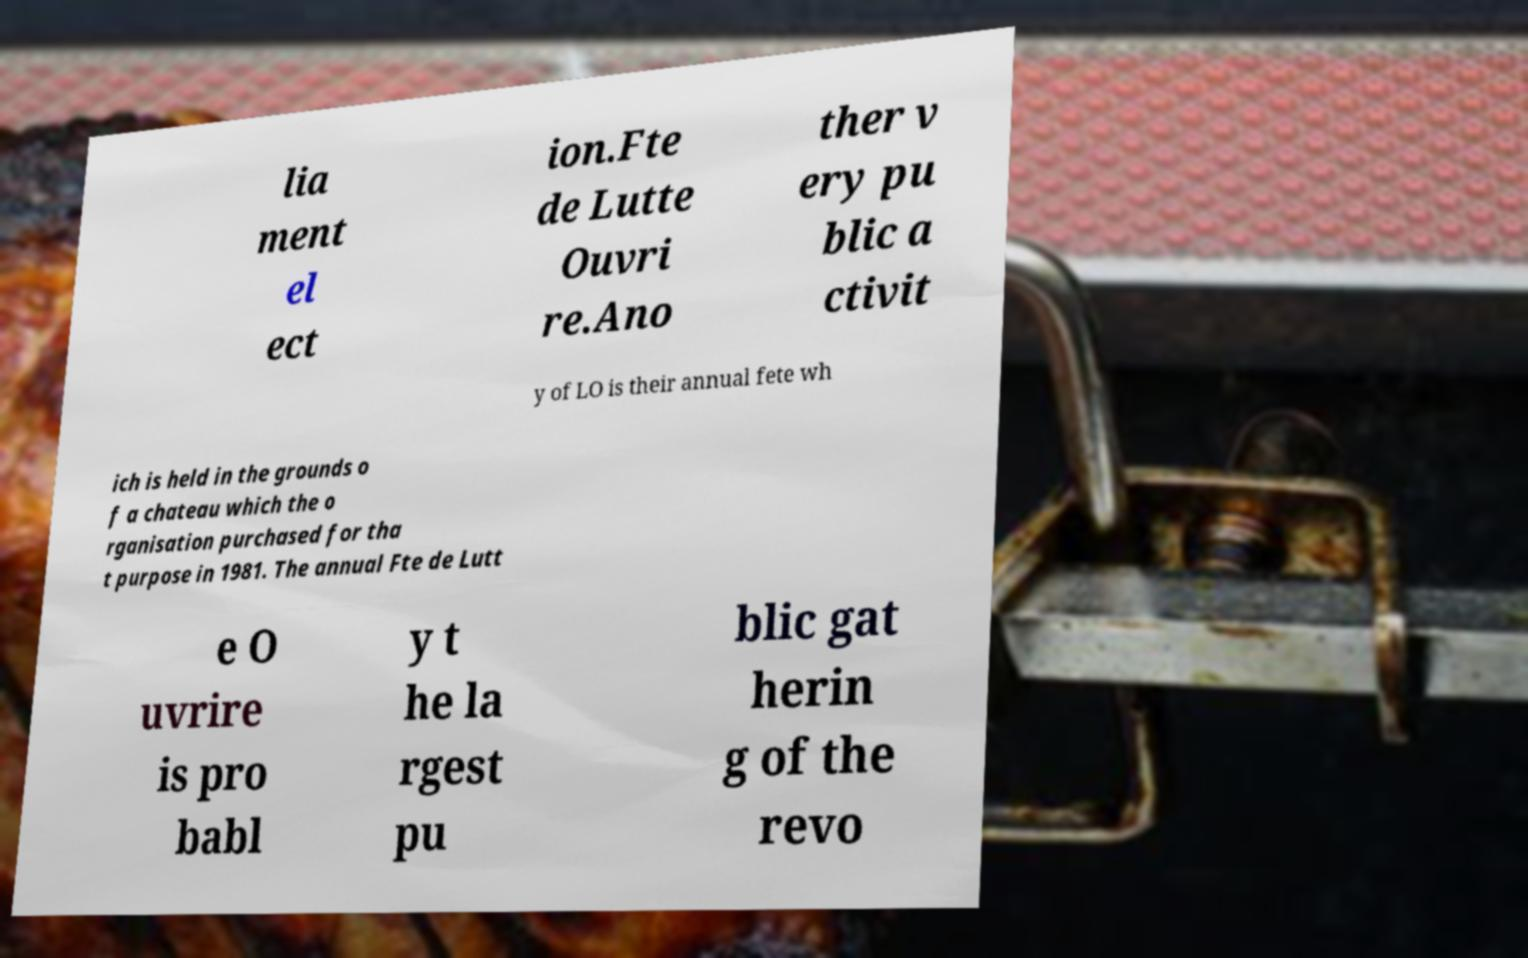Can you accurately transcribe the text from the provided image for me? lia ment el ect ion.Fte de Lutte Ouvri re.Ano ther v ery pu blic a ctivit y of LO is their annual fete wh ich is held in the grounds o f a chateau which the o rganisation purchased for tha t purpose in 1981. The annual Fte de Lutt e O uvrire is pro babl y t he la rgest pu blic gat herin g of the revo 